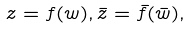Convert formula to latex. <formula><loc_0><loc_0><loc_500><loc_500>z = f ( w ) , \bar { z } = \bar { f } ( \bar { w } ) ,</formula> 